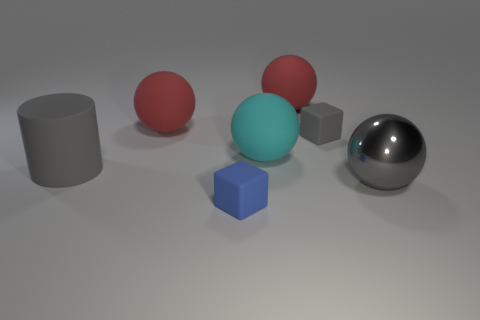Add 2 tiny gray objects. How many objects exist? 9 Subtract all spheres. How many objects are left? 3 Subtract all large purple metal balls. Subtract all tiny gray rubber objects. How many objects are left? 6 Add 1 big matte objects. How many big matte objects are left? 5 Add 3 large metal balls. How many large metal balls exist? 4 Subtract 0 purple blocks. How many objects are left? 7 